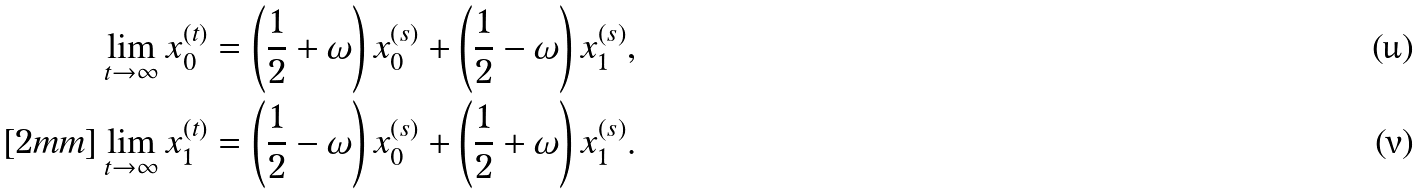Convert formula to latex. <formula><loc_0><loc_0><loc_500><loc_500>\lim _ { t \to \infty } x _ { 0 } ^ { ( t ) } & = \left ( \frac { 1 } { 2 } + \omega \right ) x _ { 0 } ^ { ( s ) } + \left ( \frac { 1 } { 2 } - \omega \right ) x _ { 1 } ^ { ( s ) } , \\ [ 2 m m ] \lim _ { t \to \infty } x _ { 1 } ^ { ( t ) } & = \left ( \frac { 1 } { 2 } - \omega \right ) x _ { 0 } ^ { ( s ) } + \left ( \frac { 1 } { 2 } + \omega \right ) x _ { 1 } ^ { ( s ) } .</formula> 